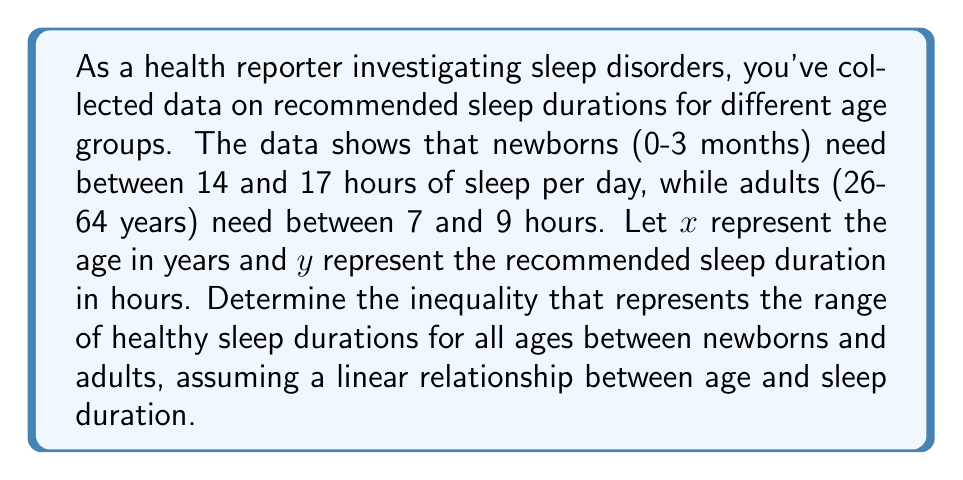Teach me how to tackle this problem. 1) First, we need to identify our two data points:
   - Newborns (0 years): 14-17 hours
   - Adults (64 years): 7-9 hours

2) We'll use the midpoints of these ranges for our calculations:
   - Newborns: $(0, 15.5)$
   - Adults: $(64, 8)$

3) Calculate the slope of the line:
   $m = \frac{y_2 - y_1}{x_2 - x_1} = \frac{8 - 15.5}{64 - 0} = -\frac{7.5}{64} \approx -0.117$

4) Using the point-slope form of a line, we can write the equation:
   $y - 15.5 = -\frac{7.5}{64}(x - 0)$

5) Simplify:
   $y = -\frac{7.5}{64}x + 15.5$

6) To account for the range, we need to add and subtract 1.5 hours (half the range width for both newborns and adults):
   Lower bound: $y = -\frac{7.5}{64}x + 14$
   Upper bound: $y = -\frac{7.5}{64}x + 17$

7) Combine these into an inequality:
   $-\frac{7.5}{64}x + 14 \leq y \leq -\frac{7.5}{64}x + 17$

8) This inequality represents the range of healthy sleep durations for ages 0 to 64 years.
Answer: $$-\frac{7.5}{64}x + 14 \leq y \leq -\frac{7.5}{64}x + 17, \text{ where } 0 \leq x \leq 64$$ 